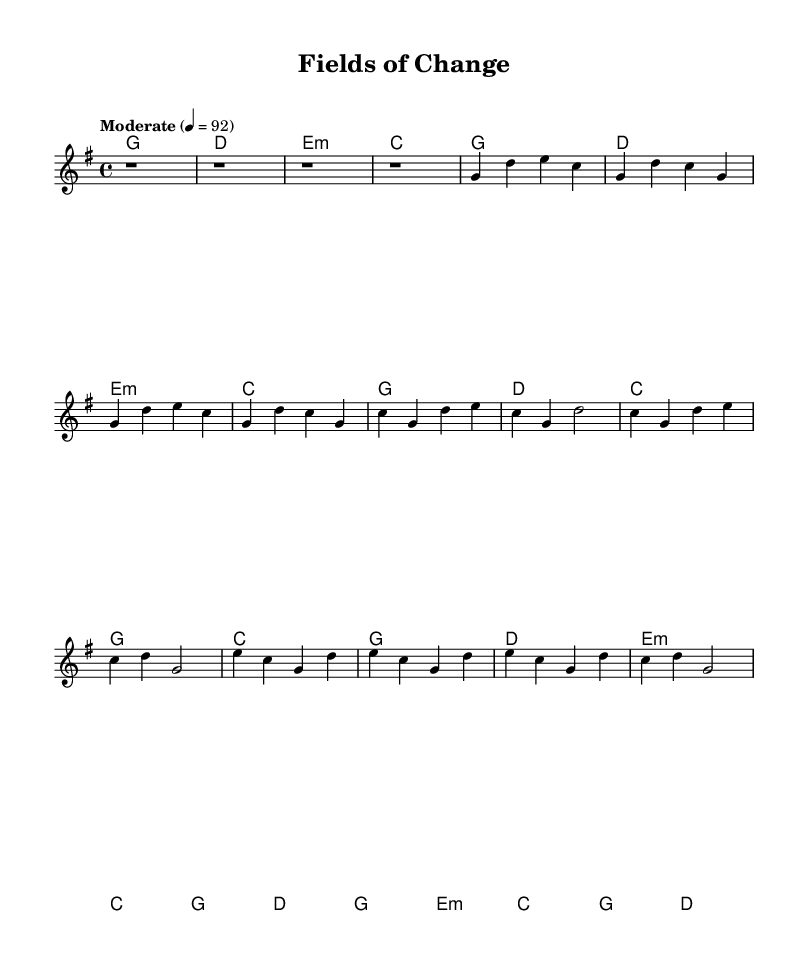What is the key signature of this music? The key signature is G major, which has one sharp (F#). This can be determined by locating the key signature section at the beginning of the piece where G major is indicated.
Answer: G major What is the time signature of this music? The time signature is 4/4, which means there are four beats in each measure and a quarter note receives one beat. This is visible right after the key signature at the beginning of the staff.
Answer: 4/4 What is the tempo marking for this piece? The tempo marking is "Moderate" at a speed of 92 beats per minute, which guides how the piece should be played. This is indicated at the start of the music sheet, just below the title.
Answer: Moderate How many measures are in the verse section? The verse section consists of four measures, which can be identified by counting the measures represented in the melody for that section. Each group of four beats creates one measure, and the melody line clearly lays out four distinct measures for the verse.
Answer: 4 Which chords are used in the chorus? The chords used in the chorus are C, G, D, and E minor. This is determined by examining the chord progression written above the melody lines specifically for the chorus section.
Answer: C, G, D, E minor What musical structure does this piece follow primarily? This piece follows a verse-chorus structure, typical of country rock, where the song alternates between verses and choruses, allowing for storytelling and musical hooks. This can be inferred from the layout of the sections labeled "Verse" and "Chorus" in the music.
Answer: Verse-chorus What is the name of this piece? The name of this piece is "Fields of Change," which is indicated at the top of the music sheet in the header section. The title reflects the song's themes, likely related to the changing landscape of farmland.
Answer: Fields of Change 